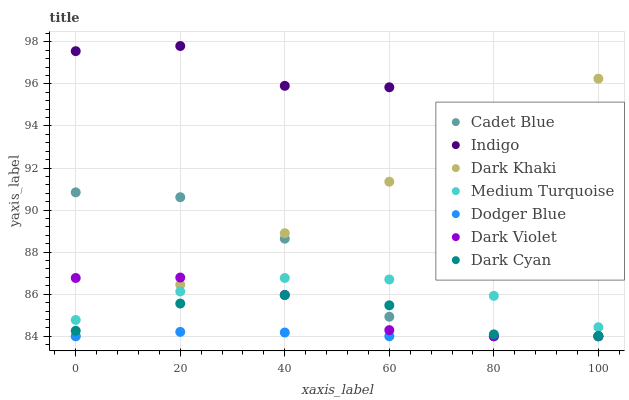Does Dodger Blue have the minimum area under the curve?
Answer yes or no. Yes. Does Indigo have the maximum area under the curve?
Answer yes or no. Yes. Does Dark Violet have the minimum area under the curve?
Answer yes or no. No. Does Dark Violet have the maximum area under the curve?
Answer yes or no. No. Is Dark Khaki the smoothest?
Answer yes or no. Yes. Is Cadet Blue the roughest?
Answer yes or no. Yes. Is Indigo the smoothest?
Answer yes or no. No. Is Indigo the roughest?
Answer yes or no. No. Does Cadet Blue have the lowest value?
Answer yes or no. Yes. Does Indigo have the lowest value?
Answer yes or no. No. Does Indigo have the highest value?
Answer yes or no. Yes. Does Dark Violet have the highest value?
Answer yes or no. No. Is Medium Turquoise less than Indigo?
Answer yes or no. Yes. Is Indigo greater than Cadet Blue?
Answer yes or no. Yes. Does Dark Cyan intersect Dark Violet?
Answer yes or no. Yes. Is Dark Cyan less than Dark Violet?
Answer yes or no. No. Is Dark Cyan greater than Dark Violet?
Answer yes or no. No. Does Medium Turquoise intersect Indigo?
Answer yes or no. No. 